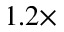Convert formula to latex. <formula><loc_0><loc_0><loc_500><loc_500>1 . 2 \times</formula> 